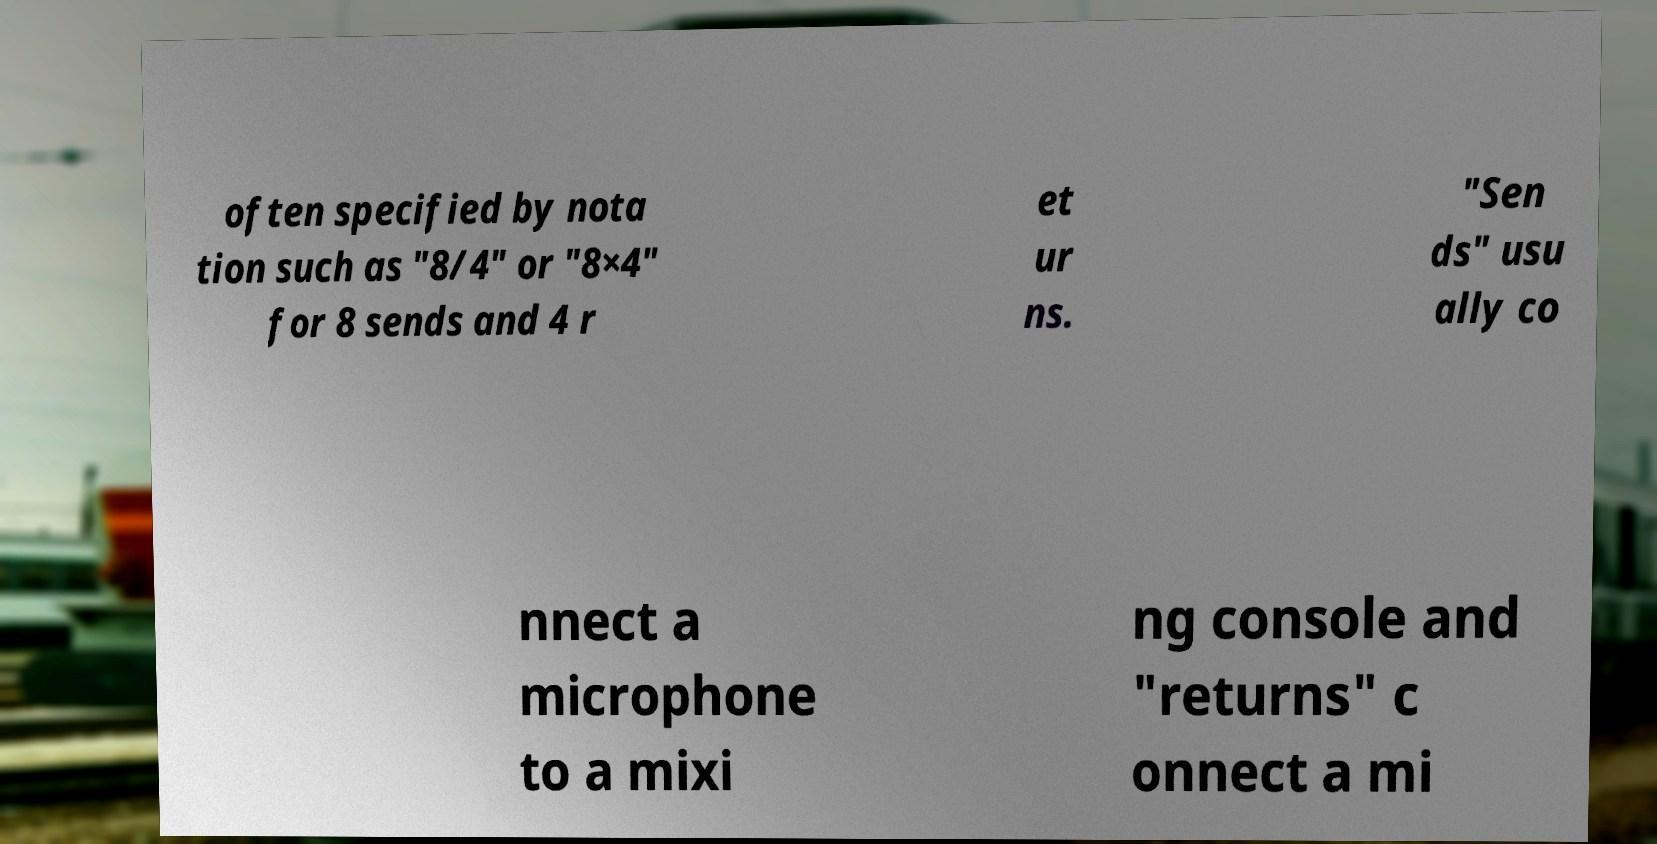Could you extract and type out the text from this image? often specified by nota tion such as "8/4" or "8×4" for 8 sends and 4 r et ur ns. "Sen ds" usu ally co nnect a microphone to a mixi ng console and "returns" c onnect a mi 